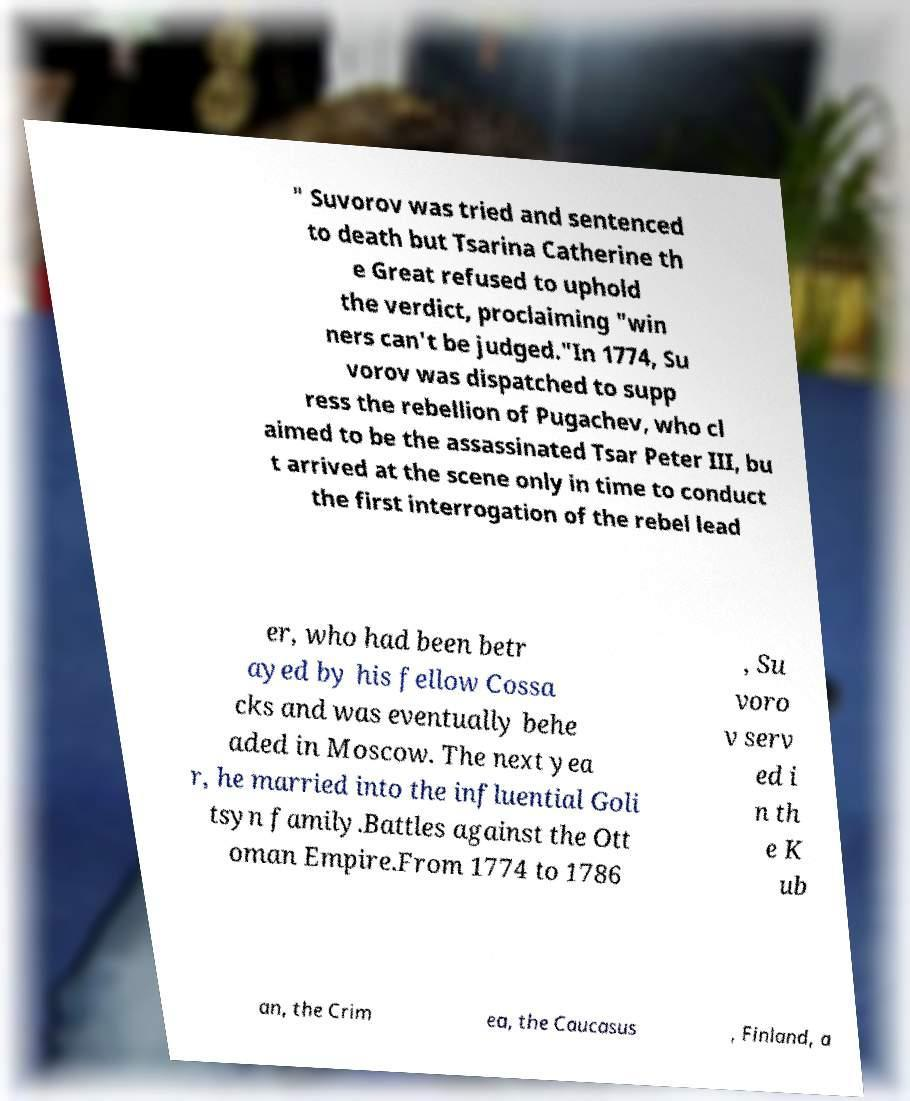What messages or text are displayed in this image? I need them in a readable, typed format. " Suvorov was tried and sentenced to death but Tsarina Catherine th e Great refused to uphold the verdict, proclaiming "win ners can't be judged."In 1774, Su vorov was dispatched to supp ress the rebellion of Pugachev, who cl aimed to be the assassinated Tsar Peter III, bu t arrived at the scene only in time to conduct the first interrogation of the rebel lead er, who had been betr ayed by his fellow Cossa cks and was eventually behe aded in Moscow. The next yea r, he married into the influential Goli tsyn family.Battles against the Ott oman Empire.From 1774 to 1786 , Su voro v serv ed i n th e K ub an, the Crim ea, the Caucasus , Finland, a 